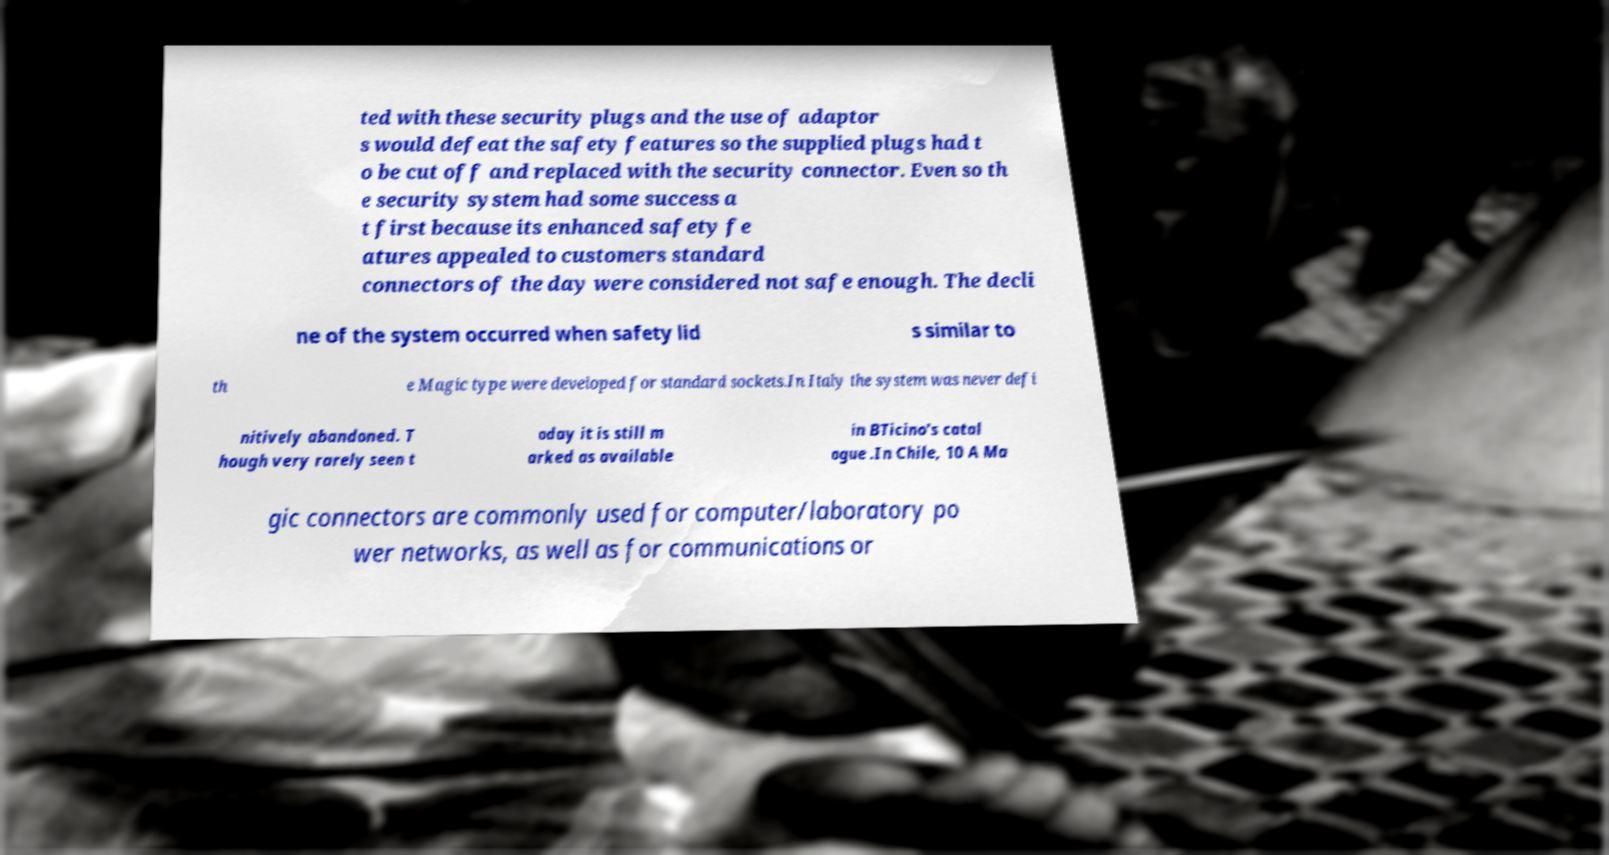Could you assist in decoding the text presented in this image and type it out clearly? ted with these security plugs and the use of adaptor s would defeat the safety features so the supplied plugs had t o be cut off and replaced with the security connector. Even so th e security system had some success a t first because its enhanced safety fe atures appealed to customers standard connectors of the day were considered not safe enough. The decli ne of the system occurred when safety lid s similar to th e Magic type were developed for standard sockets.In Italy the system was never defi nitively abandoned. T hough very rarely seen t oday it is still m arked as available in BTicino’s catal ogue .In Chile, 10 A Ma gic connectors are commonly used for computer/laboratory po wer networks, as well as for communications or 